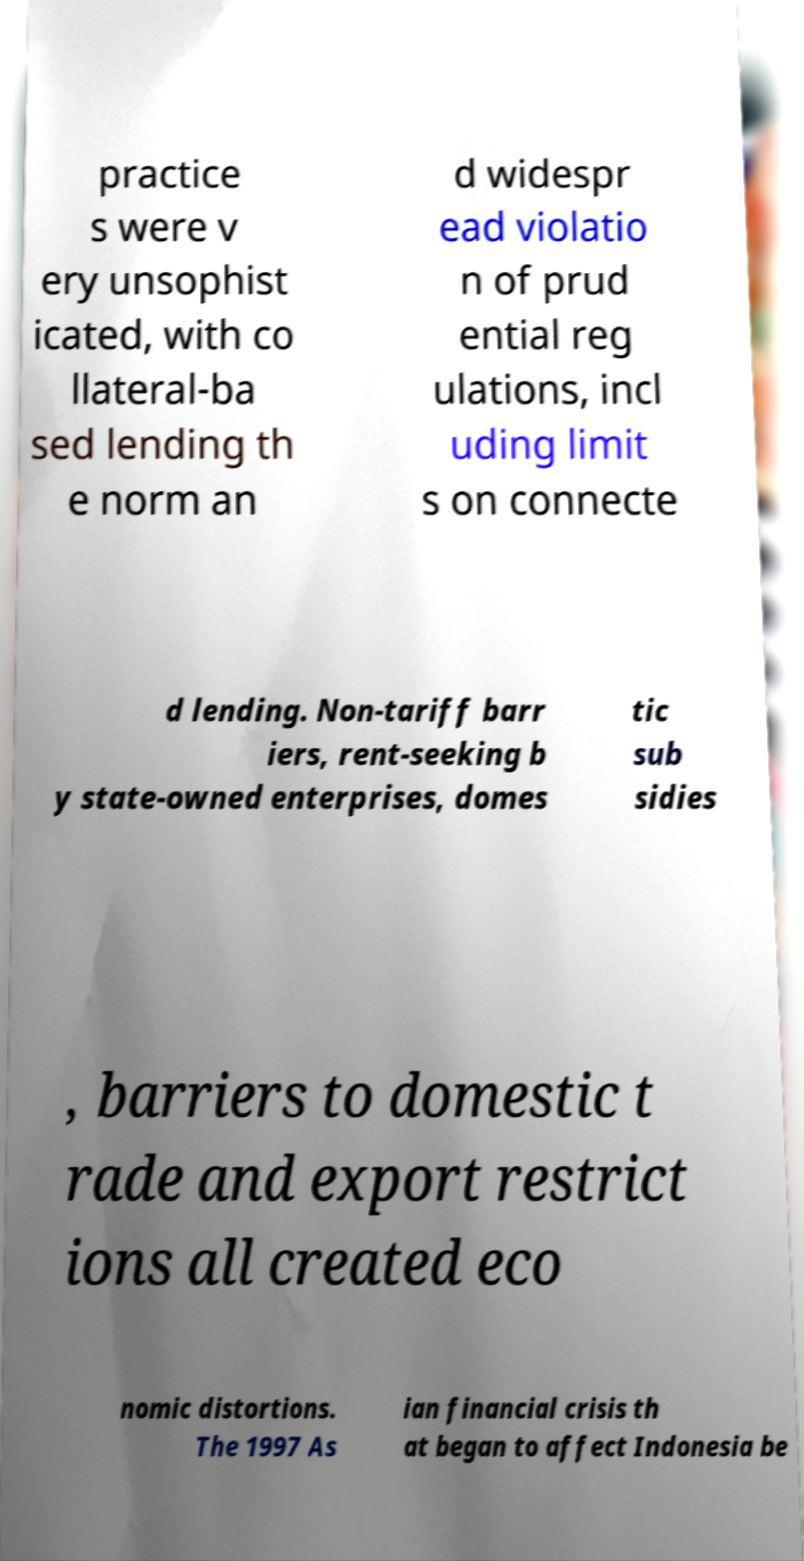Can you read and provide the text displayed in the image?This photo seems to have some interesting text. Can you extract and type it out for me? practice s were v ery unsophist icated, with co llateral-ba sed lending th e norm an d widespr ead violatio n of prud ential reg ulations, incl uding limit s on connecte d lending. Non-tariff barr iers, rent-seeking b y state-owned enterprises, domes tic sub sidies , barriers to domestic t rade and export restrict ions all created eco nomic distortions. The 1997 As ian financial crisis th at began to affect Indonesia be 